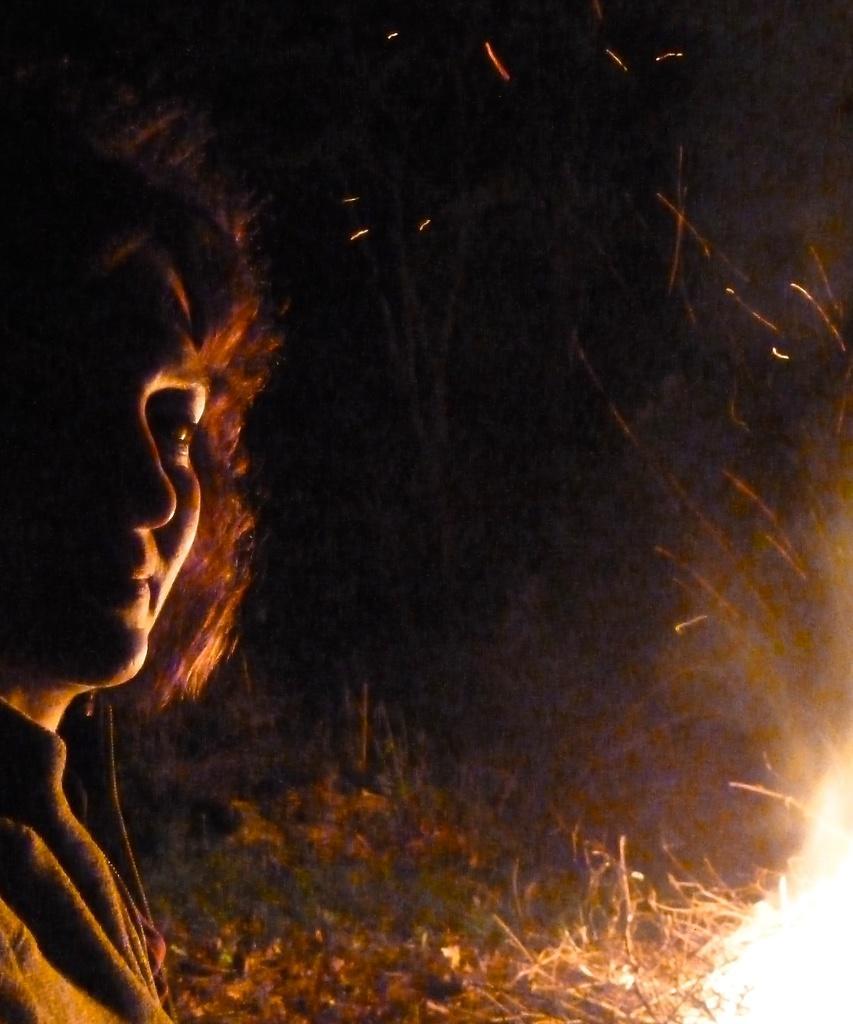Can you describe this image briefly? This is an image clicked in the dark. On the left side there is a person looking at the picture. In the bottom right-hand corner, I can see the fire. There are few sticks and grass on the ground. The background is dark. 